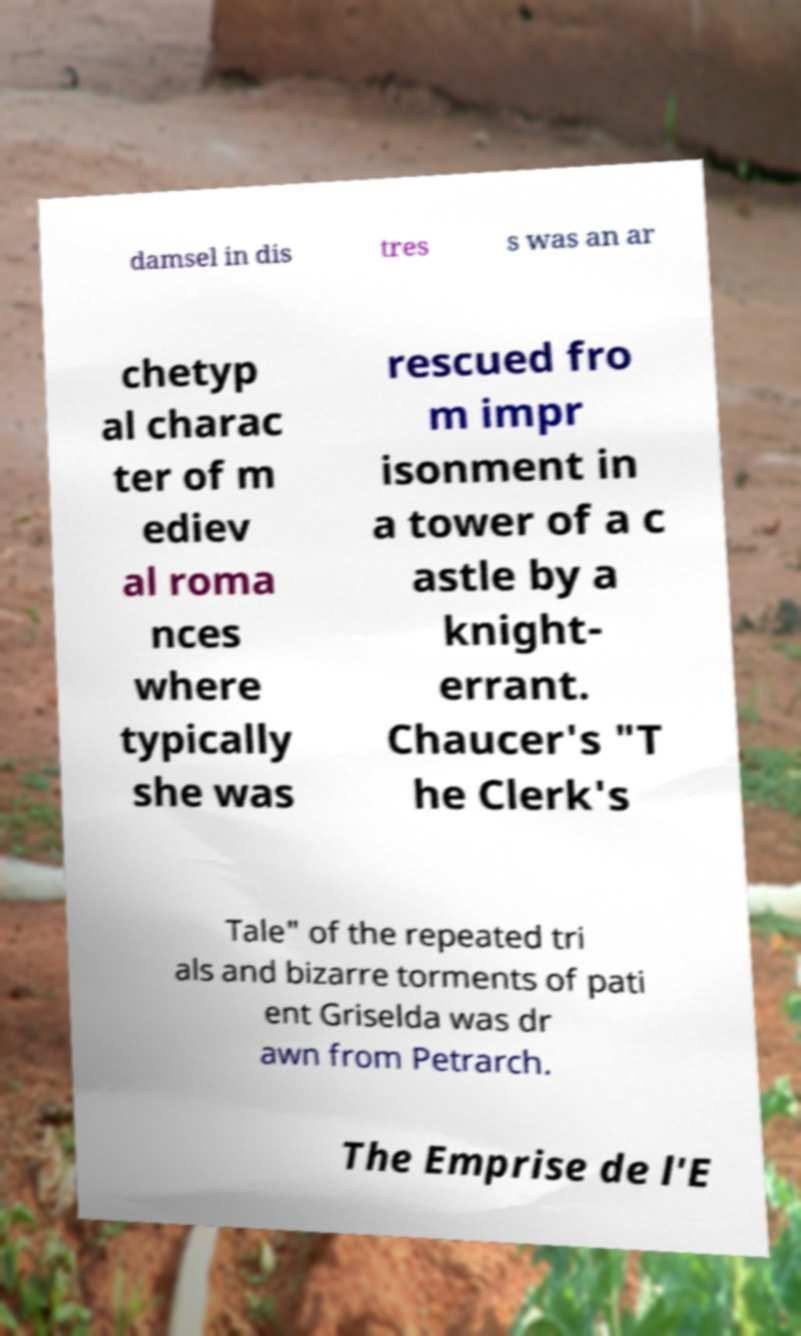What messages or text are displayed in this image? I need them in a readable, typed format. damsel in dis tres s was an ar chetyp al charac ter of m ediev al roma nces where typically she was rescued fro m impr isonment in a tower of a c astle by a knight- errant. Chaucer's "T he Clerk's Tale" of the repeated tri als and bizarre torments of pati ent Griselda was dr awn from Petrarch. The Emprise de l'E 